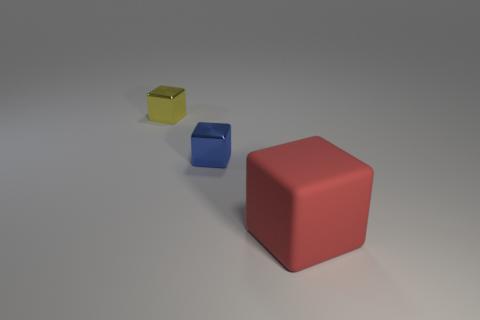What size is the blue shiny block?
Offer a terse response. Small. Is there anything else that has the same material as the blue block?
Your answer should be compact. Yes. Are there any tiny yellow shiny blocks that are left of the small block on the left side of the tiny block right of the small yellow metal object?
Your answer should be compact. No. How many tiny things are either rubber blocks or yellow shiny cubes?
Provide a short and direct response. 1. Are there any other things that have the same color as the big rubber object?
Keep it short and to the point. No. Is the size of the metallic object left of the blue metallic object the same as the tiny blue object?
Your answer should be very brief. Yes. The small metallic block that is behind the blue metallic block that is in front of the object that is left of the small blue metallic thing is what color?
Provide a succinct answer. Yellow. What color is the big rubber block?
Your answer should be very brief. Red. Is the material of the small cube that is on the right side of the yellow shiny block the same as the cube to the right of the small blue shiny thing?
Ensure brevity in your answer.  No. There is a yellow thing that is the same shape as the red matte thing; what is its material?
Your answer should be very brief. Metal. 